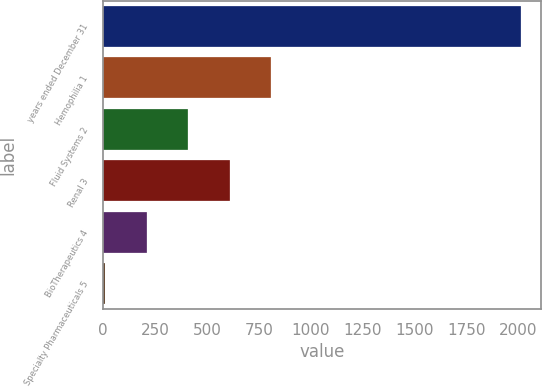Convert chart to OTSL. <chart><loc_0><loc_0><loc_500><loc_500><bar_chart><fcel>years ended December 31<fcel>Hemophilia 1<fcel>Fluid Systems 2<fcel>Renal 3<fcel>BioTherapeutics 4<fcel>Specialty Pharmaceuticals 5<nl><fcel>2013<fcel>811.2<fcel>410.6<fcel>610.9<fcel>210.3<fcel>10<nl></chart> 